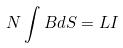<formula> <loc_0><loc_0><loc_500><loc_500>N \int B d S = L I</formula> 